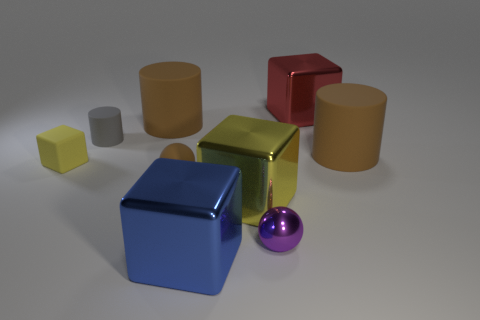Subtract all blocks. How many objects are left? 5 Subtract all green metal cubes. Subtract all blue metallic cubes. How many objects are left? 8 Add 5 red objects. How many red objects are left? 6 Add 1 large brown objects. How many large brown objects exist? 3 Subtract 0 green spheres. How many objects are left? 9 